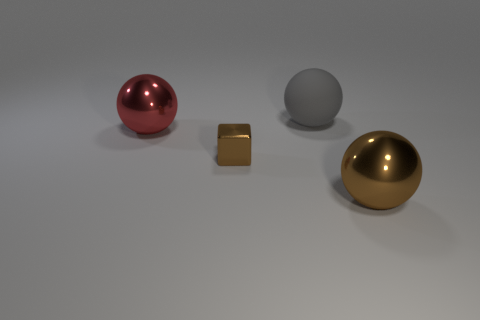What number of other things are the same color as the small shiny cube?
Provide a short and direct response. 1. What is the material of the large sphere on the left side of the object that is behind the ball that is left of the small brown metal thing?
Your response must be concise. Metal. What material is the brown thing to the left of the brown metallic object in front of the tiny brown metallic object?
Your answer should be very brief. Metal. Is the number of rubber things on the right side of the small brown thing less than the number of large matte spheres?
Ensure brevity in your answer.  No. There is a shiny object on the right side of the big gray rubber ball; what shape is it?
Offer a terse response. Sphere. There is a red shiny thing; does it have the same size as the brown metal object behind the big brown object?
Give a very brief answer. No. Are there any green blocks made of the same material as the big red thing?
Your answer should be compact. No. How many balls are either big brown shiny things or blue things?
Give a very brief answer. 1. Are there any large brown things that are behind the brown thing behind the brown ball?
Offer a terse response. No. Are there fewer brown metal things than small green rubber balls?
Your response must be concise. No. 